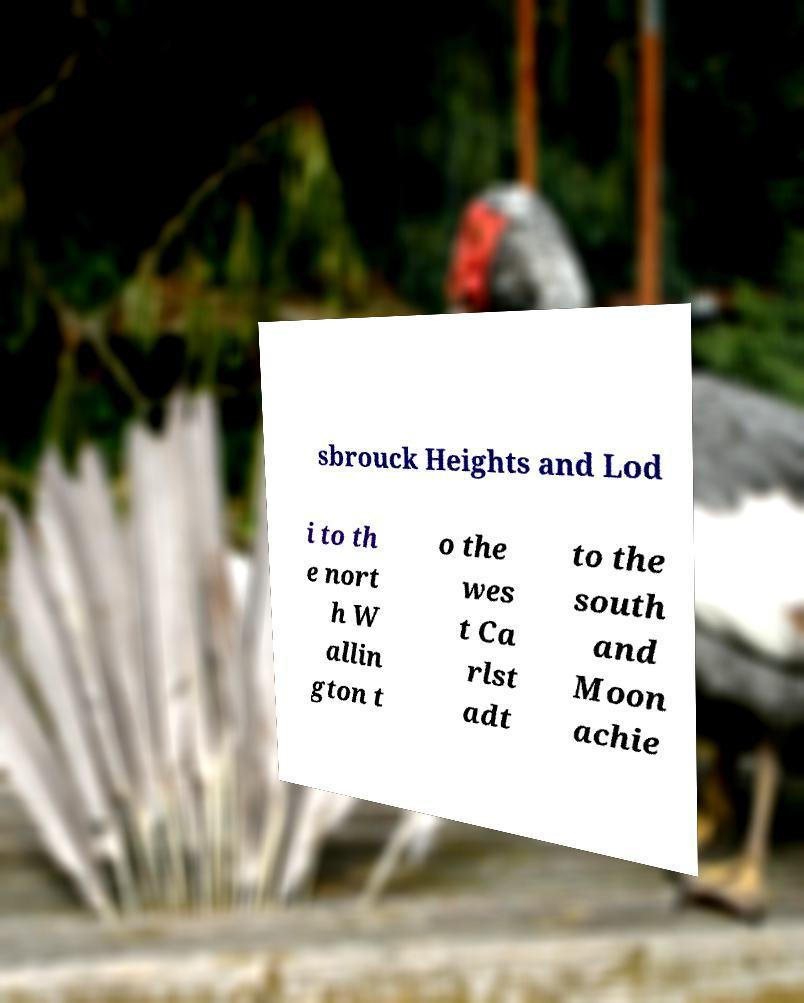Could you assist in decoding the text presented in this image and type it out clearly? sbrouck Heights and Lod i to th e nort h W allin gton t o the wes t Ca rlst adt to the south and Moon achie 